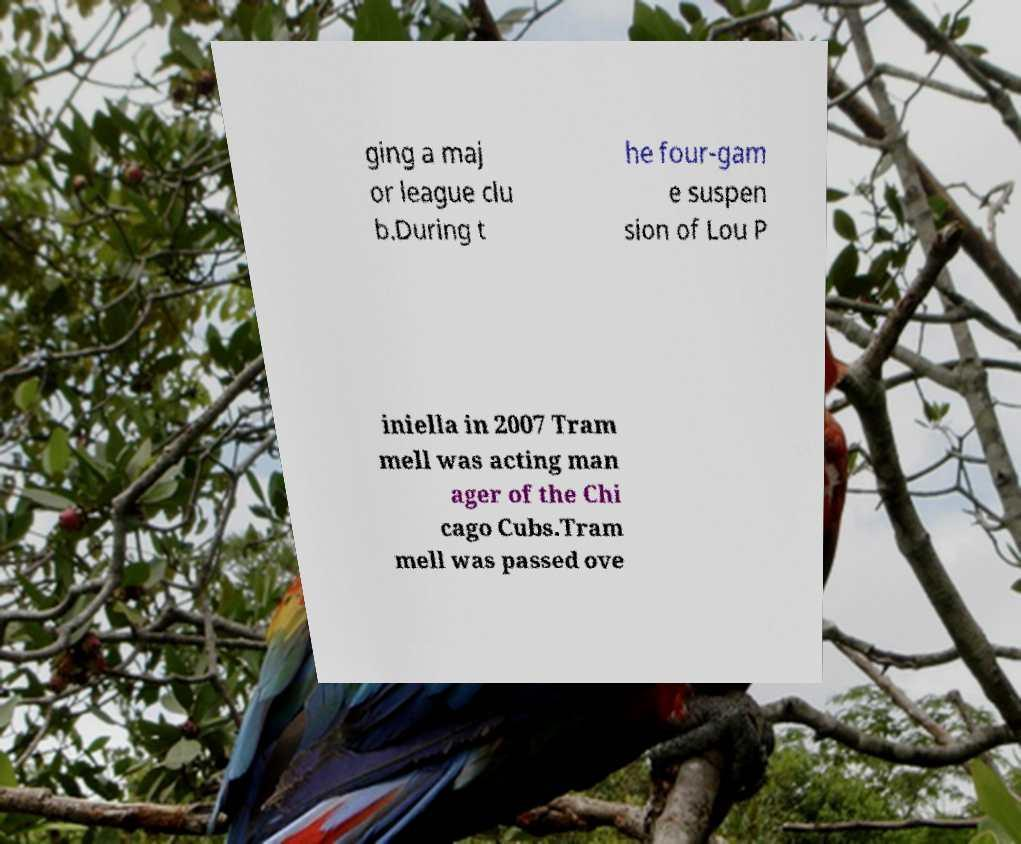I need the written content from this picture converted into text. Can you do that? ging a maj or league clu b.During t he four-gam e suspen sion of Lou P iniella in 2007 Tram mell was acting man ager of the Chi cago Cubs.Tram mell was passed ove 